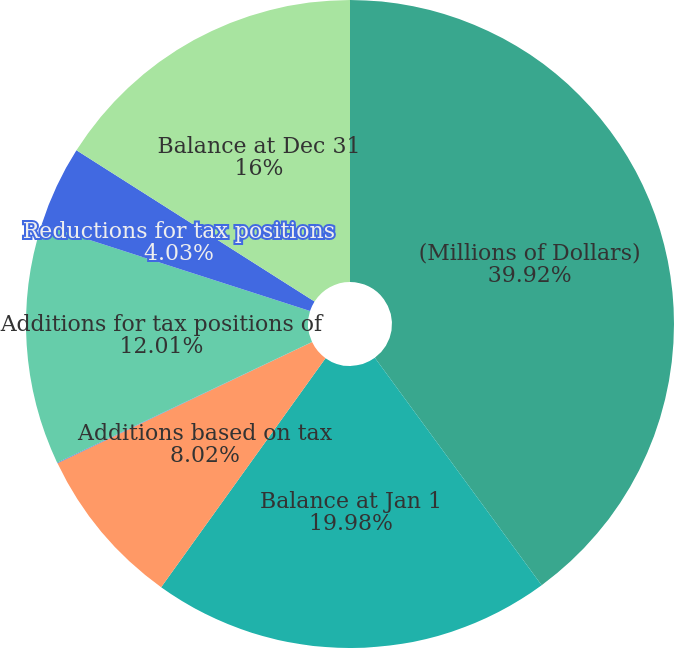Convert chart to OTSL. <chart><loc_0><loc_0><loc_500><loc_500><pie_chart><fcel>(Millions of Dollars)<fcel>Balance at Jan 1<fcel>Additions based on tax<fcel>Reductions based on tax<fcel>Additions for tax positions of<fcel>Reductions for tax positions<fcel>Balance at Dec 31<nl><fcel>39.93%<fcel>19.98%<fcel>8.02%<fcel>0.04%<fcel>12.01%<fcel>4.03%<fcel>16.0%<nl></chart> 